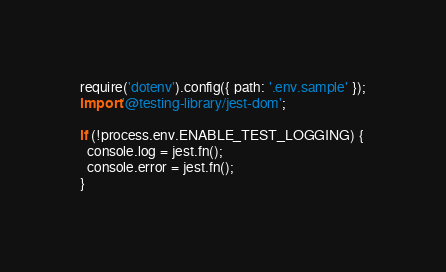<code> <loc_0><loc_0><loc_500><loc_500><_JavaScript_>require('dotenv').config({ path: '.env.sample' });
import '@testing-library/jest-dom';

if (!process.env.ENABLE_TEST_LOGGING) {
  console.log = jest.fn();
  console.error = jest.fn();
}
</code> 